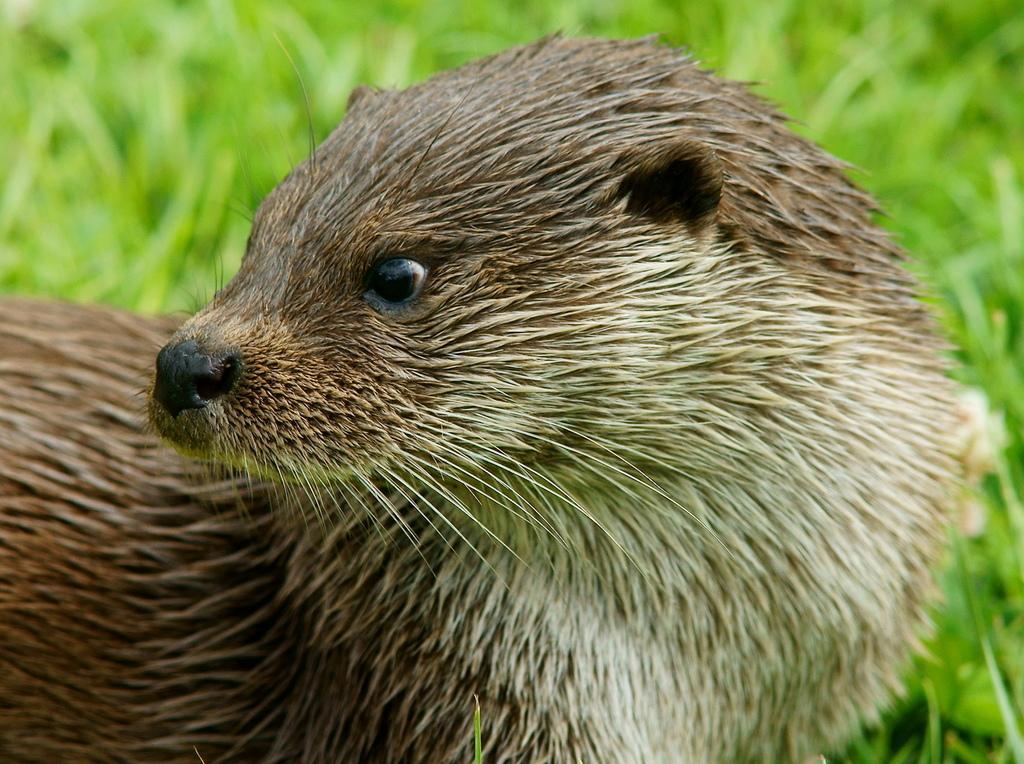Please provide a concise description of this image. In the image we can see an animal, brown and white in color. This is a grass. 